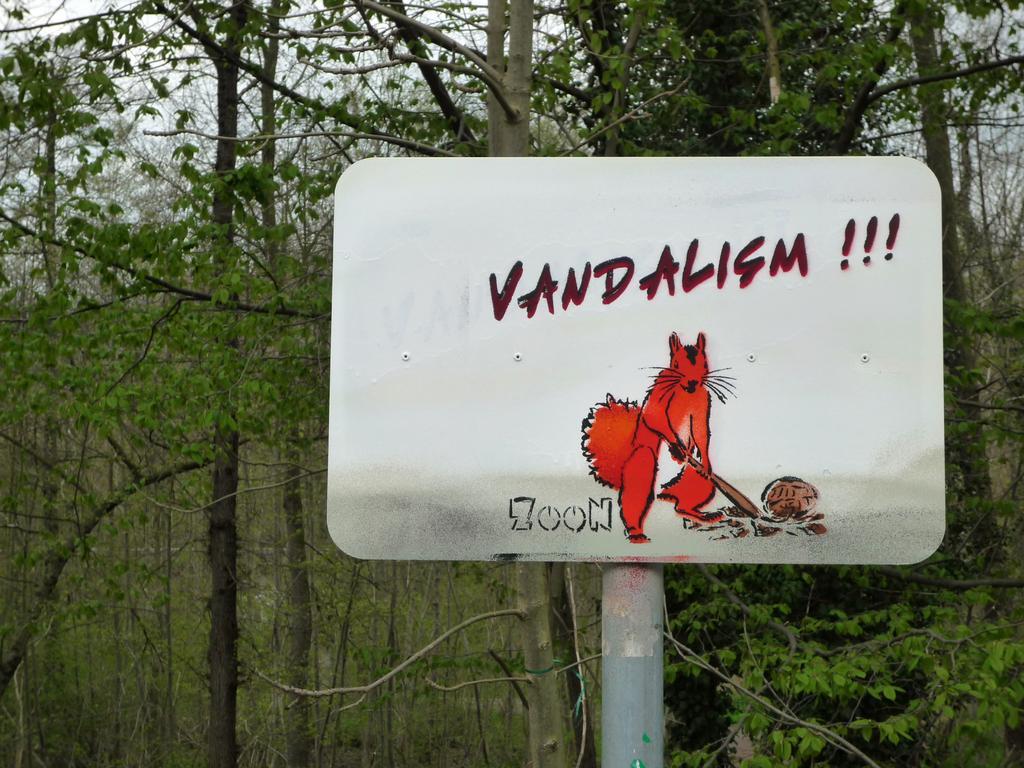Please provide a concise description of this image. In this picture we can see a board on pole. In the background of the image we can see trees and sky. 